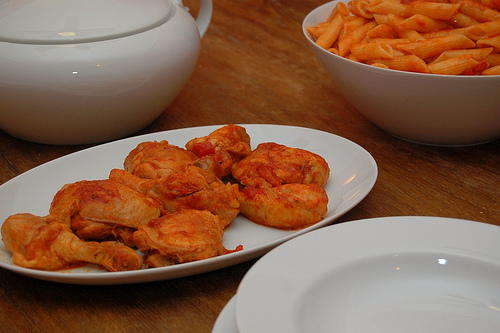<image>
Is there a chicken on the plate? Yes. Looking at the image, I can see the chicken is positioned on top of the plate, with the plate providing support. Is there a food on the plate? No. The food is not positioned on the plate. They may be near each other, but the food is not supported by or resting on top of the plate. Is there a pasta on the plate? No. The pasta is not positioned on the plate. They may be near each other, but the pasta is not supported by or resting on top of the plate. Is there a food behind the plate? Yes. From this viewpoint, the food is positioned behind the plate, with the plate partially or fully occluding the food. 